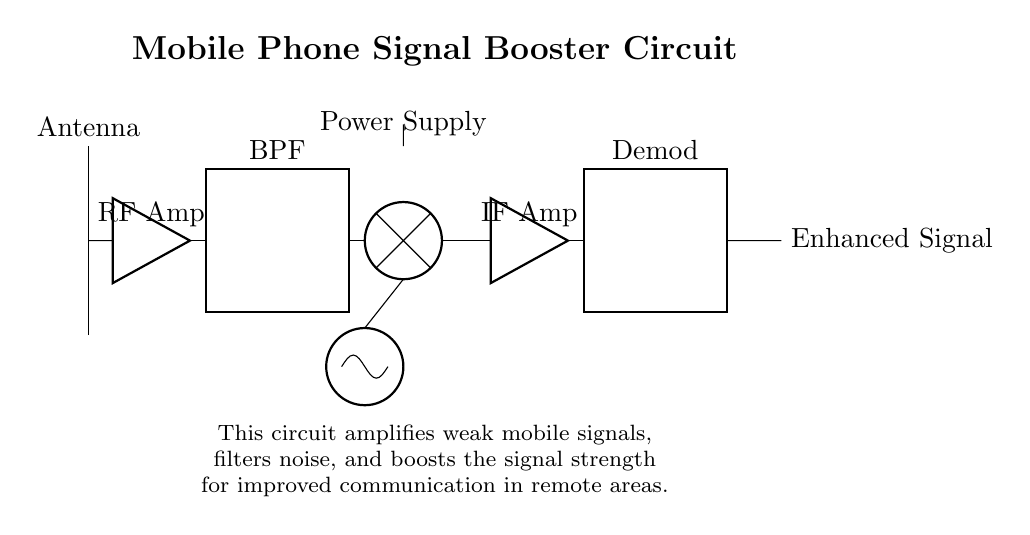What is the primary function of this circuit? The primary function of the circuit is to amplify weak mobile signals for improved communication in remote areas. This is achieved by amplifying the signal and filtering noise before outputting an enhanced signal.
Answer: Amplification How many main components are visible in this diagram? There are six main components in the circuit diagram: Antenna, RF Amplifier, Bandpass Filter, Mixer, IF Amplifier, and Demodulator. Each plays a crucial role in signal processing and enhancement.
Answer: Six What type of filter is used in this circuit? The circuit utilizes a bandpass filter (BPF), which allows signals within a certain frequency range to pass through while blocking others, helping to eliminate unwanted noise.
Answer: Bandpass Filter What does the power supply provide to the circuit? The power supply provides the necessary voltage for the circuit to operate, enabling all components to function effectively in amplifying and processing signals.
Answer: Voltage Which component is responsible for mixing signals? The mixer component is responsible for combining the input signal from the bandpass filter with the local oscillator signal to create an intermediate signal for further processing.
Answer: Mixer How does the RF amplifier contribute to the signal processing? The RF amplifier increases the strength of the weak incoming signals from the antenna, which is essential for ensuring that the signals are strong enough to be processed effectively by the subsequent components in the circuit.
Answer: Signal Strengthening What is the output of the circuit referred to as? The output of the circuit is referred to as enhanced signal, indicating that the original weak mobile signal has been amplified and processed to improve communication.
Answer: Enhanced Signal 